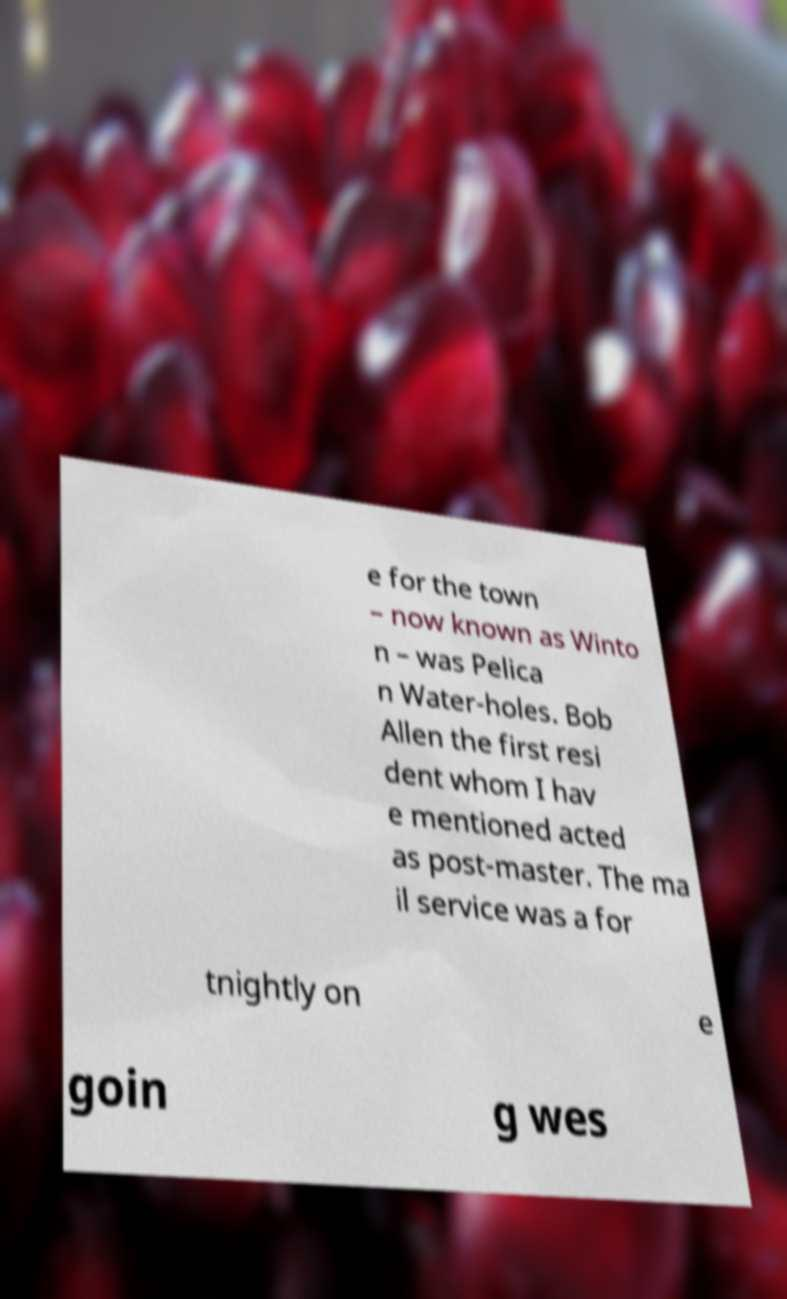Please read and relay the text visible in this image. What does it say? e for the town – now known as Winto n – was Pelica n Water-holes. Bob Allen the first resi dent whom I hav e mentioned acted as post-master. The ma il service was a for tnightly on e goin g wes 